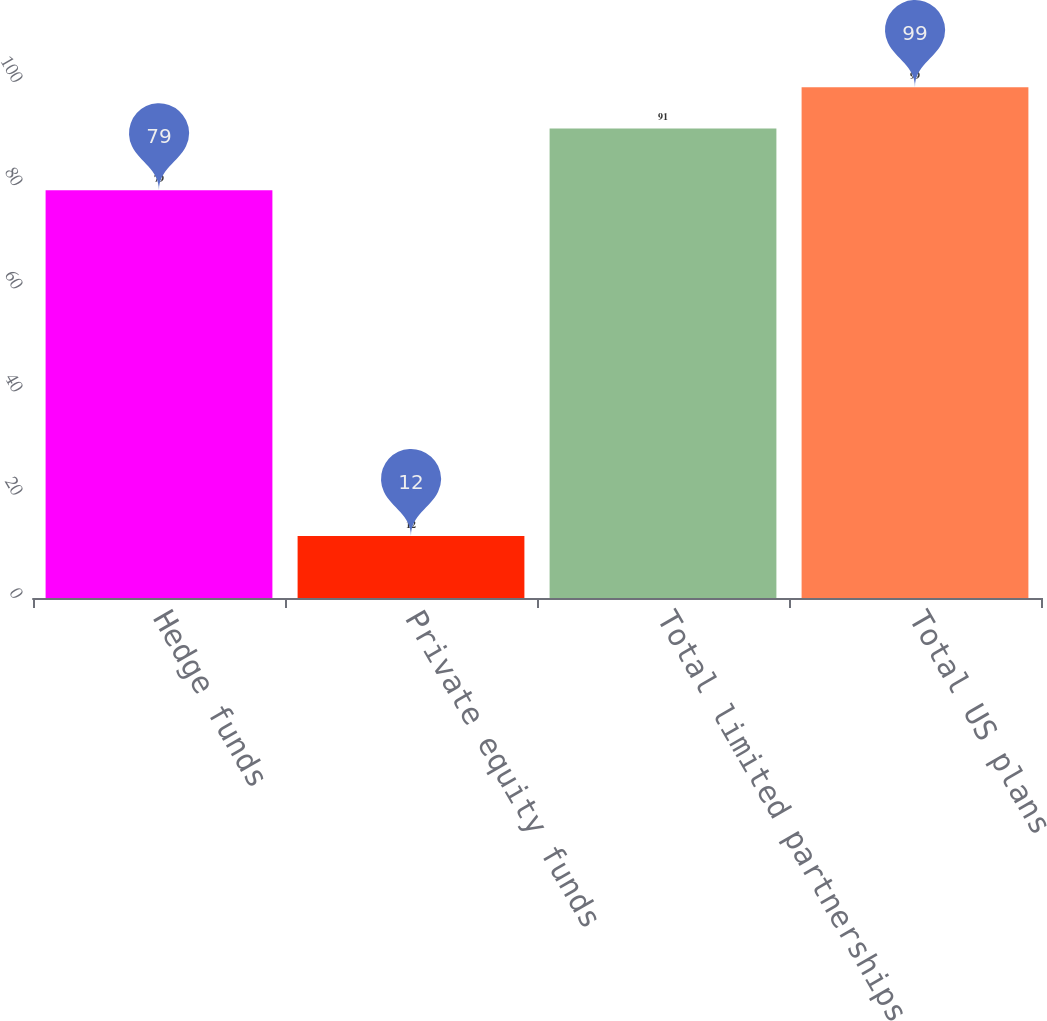Convert chart to OTSL. <chart><loc_0><loc_0><loc_500><loc_500><bar_chart><fcel>Hedge funds<fcel>Private equity funds<fcel>Total limited partnerships<fcel>Total US plans<nl><fcel>79<fcel>12<fcel>91<fcel>99<nl></chart> 